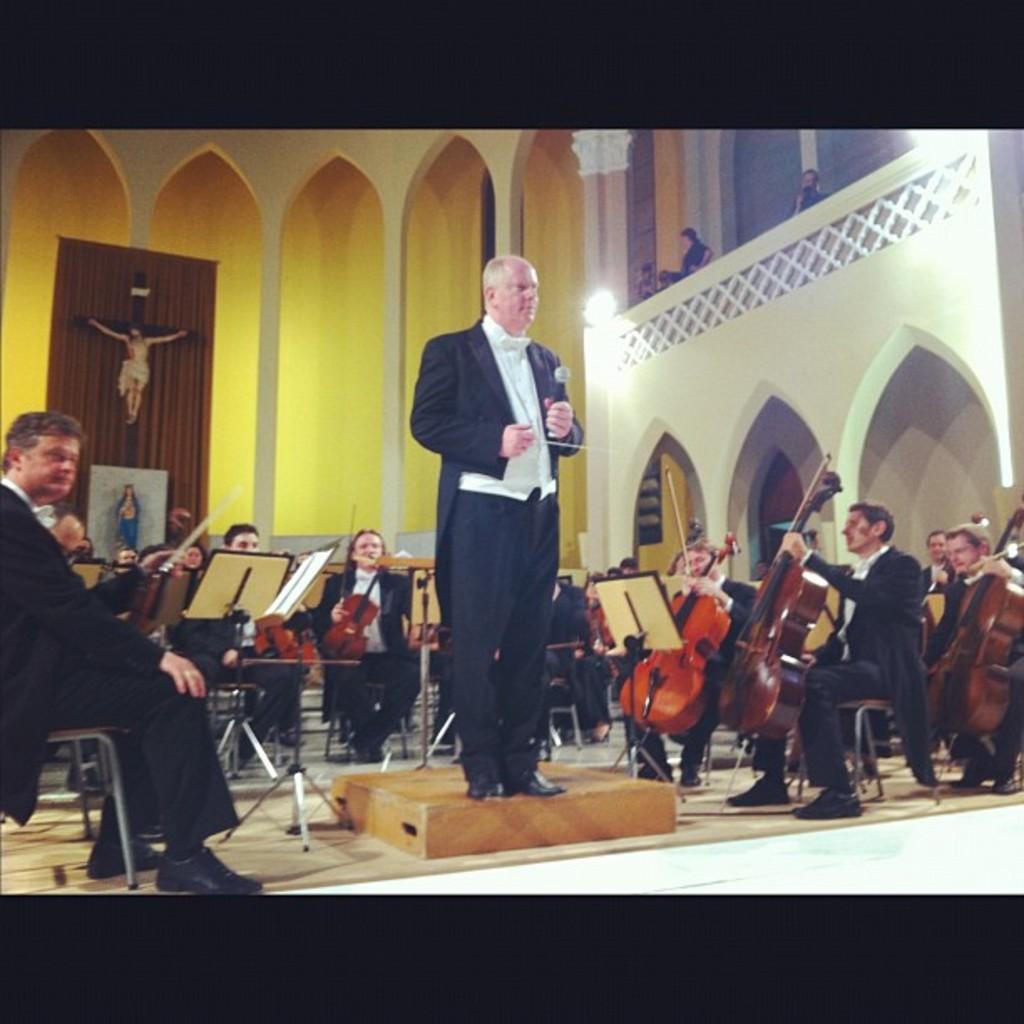Can you describe this image briefly? In this picture we can see some people are sitting on chairs and holding violins, there is a man standing in the middle, he is holding a microphone, there are some paper stands in the middle, in the background we can see a wall and Christianity symbol, on the right side there are two lights. 